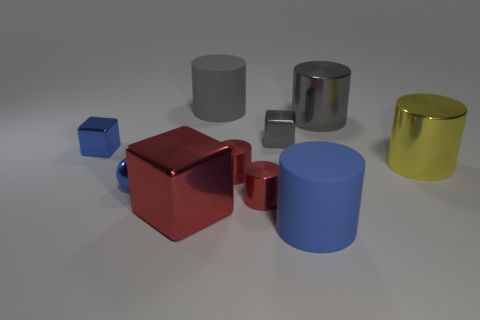Subtract all gray cylinders. How many were subtracted if there are1gray cylinders left? 1 Subtract all gray cylinders. How many cylinders are left? 4 Subtract 1 cylinders. How many cylinders are left? 5 Subtract all blue cylinders. How many cylinders are left? 5 Subtract all red cylinders. Subtract all red balls. How many cylinders are left? 4 Subtract all cylinders. How many objects are left? 4 Subtract all tiny gray objects. Subtract all large red cubes. How many objects are left? 8 Add 3 small cylinders. How many small cylinders are left? 5 Add 9 tiny balls. How many tiny balls exist? 10 Subtract 0 yellow spheres. How many objects are left? 10 